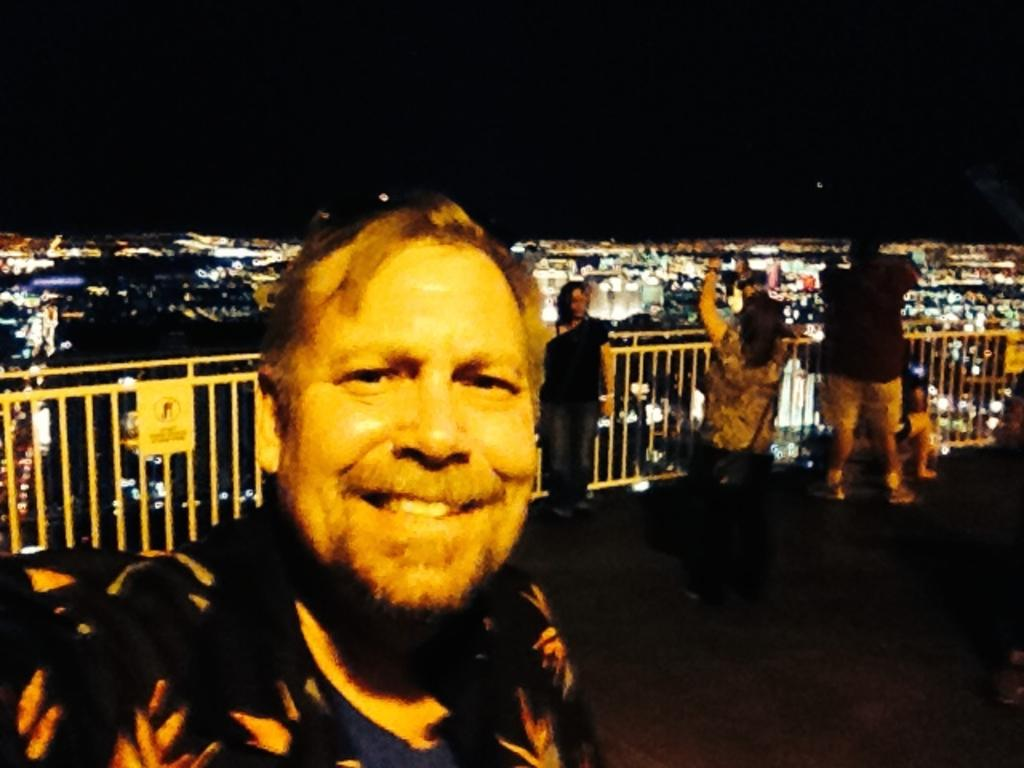What is located in the foreground of the picture? There are people and a railing in the foreground of the picture. What type of view does the image provide? The image provides an aerial view of a city. What structures can be seen in the image? There are buildings visible in the image. What can be seen in the sky in the image? There is light visible in the image, and the sky is visible at the top of the image. What type of party is being held in the image? There is no party visible in the image; it provides an aerial view of a city with buildings and a railing in the foreground. Can you see a whip being used in the image? There is no whip present in the image. 